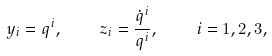<formula> <loc_0><loc_0><loc_500><loc_500>y _ { i } = q ^ { i } , \quad z _ { i } = \frac { \dot { q } ^ { i } } { q ^ { i } } , \quad i = 1 , 2 , 3 ,</formula> 